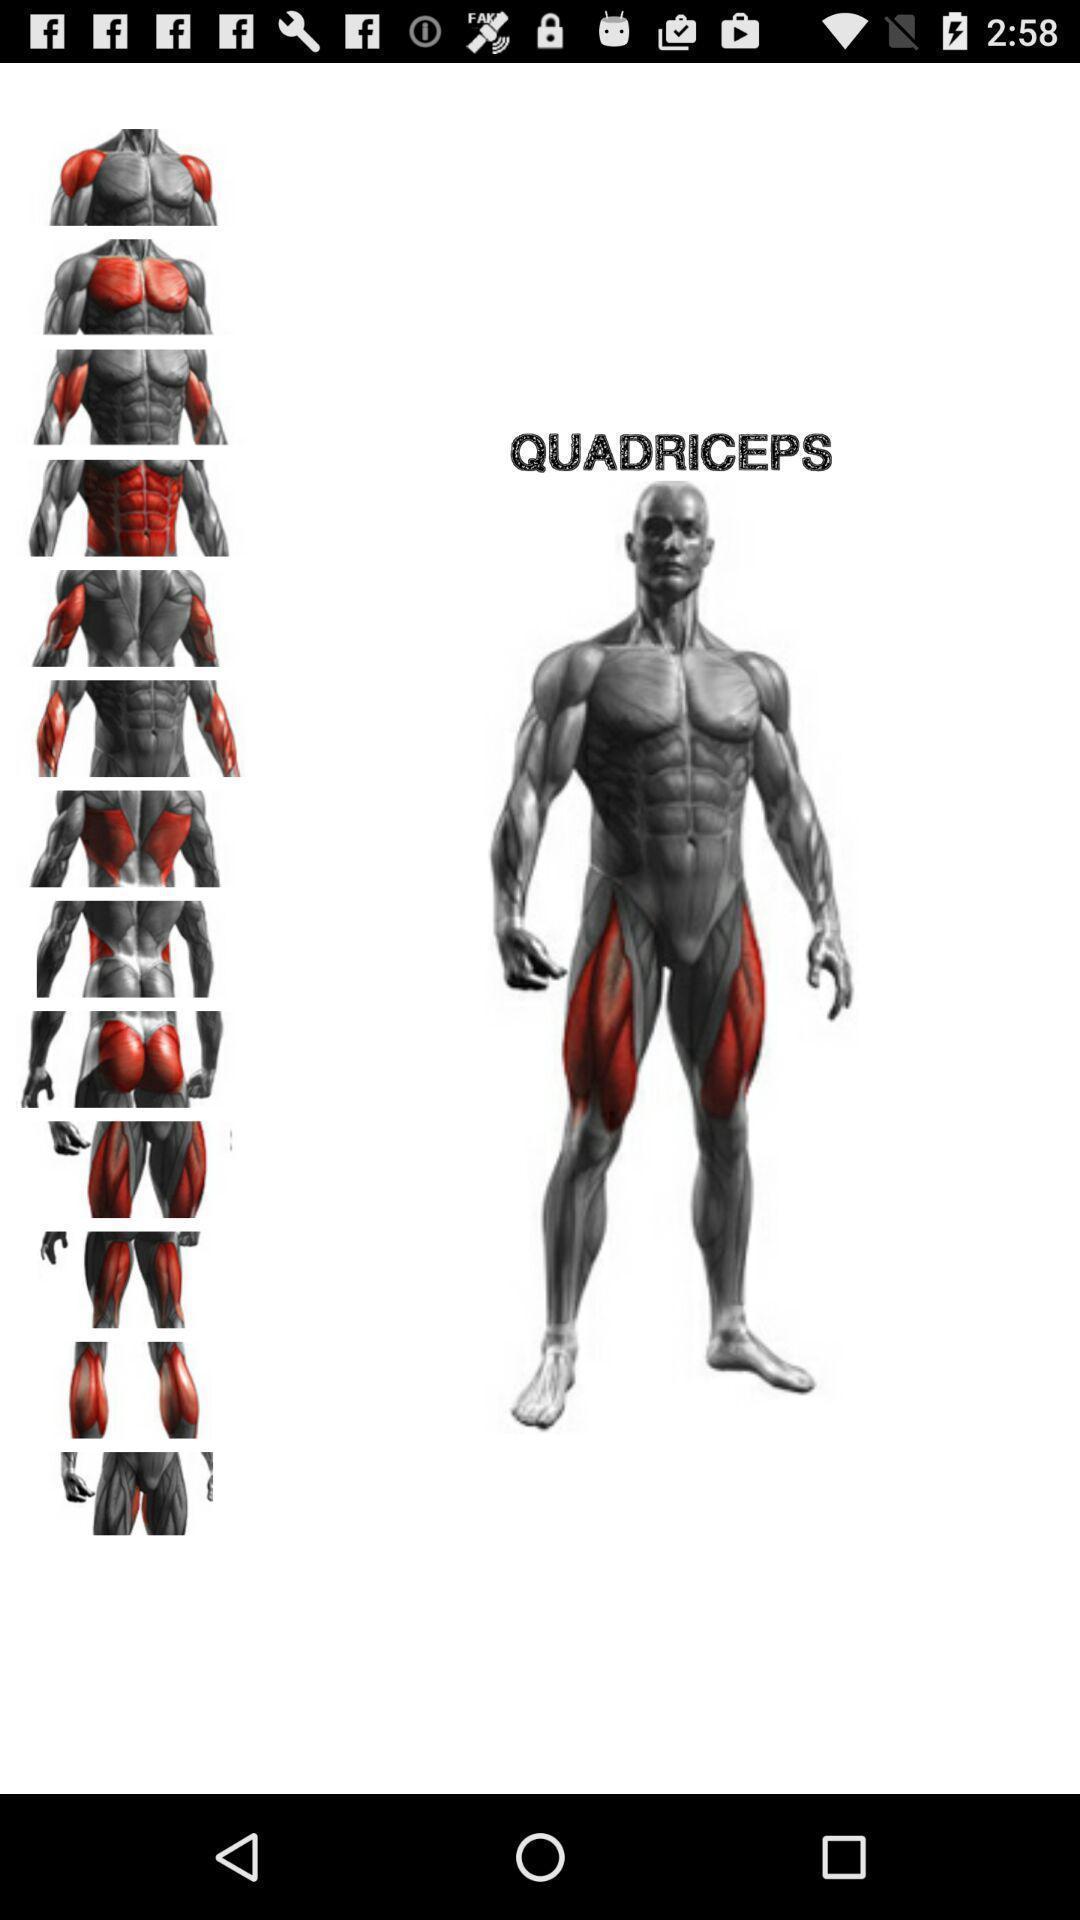Summarize the information in this screenshot. Page displaying the images of quadriceps. 